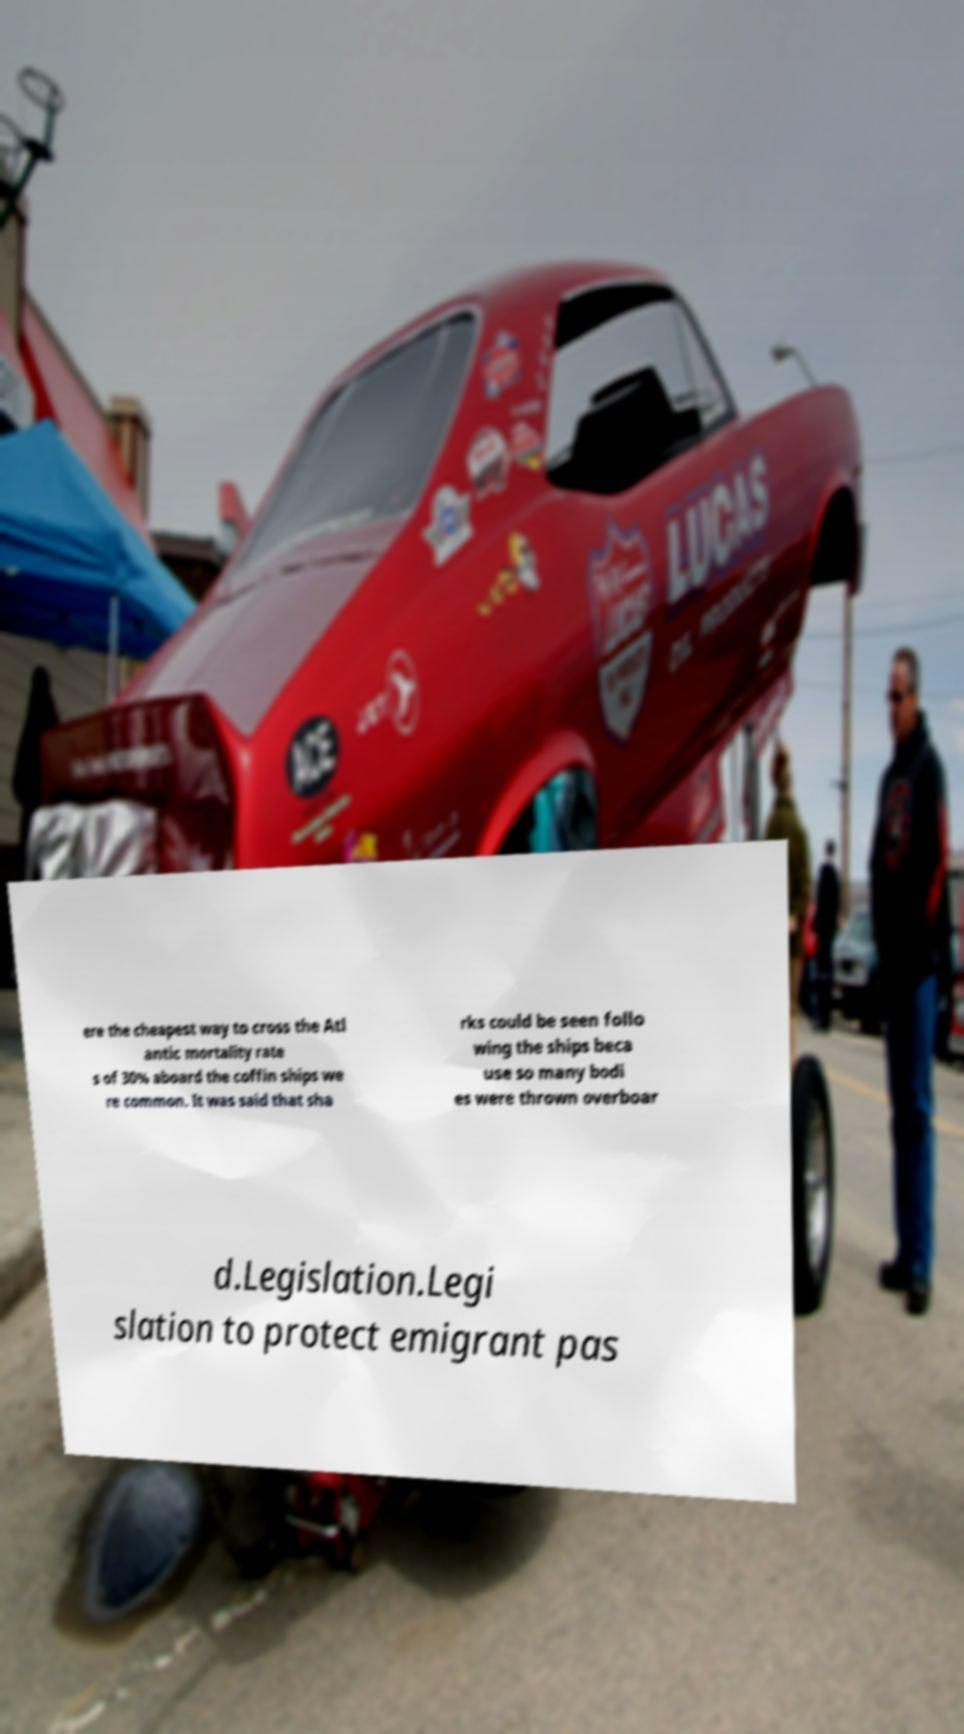Could you extract and type out the text from this image? ere the cheapest way to cross the Atl antic mortality rate s of 30% aboard the coffin ships we re common. It was said that sha rks could be seen follo wing the ships beca use so many bodi es were thrown overboar d.Legislation.Legi slation to protect emigrant pas 